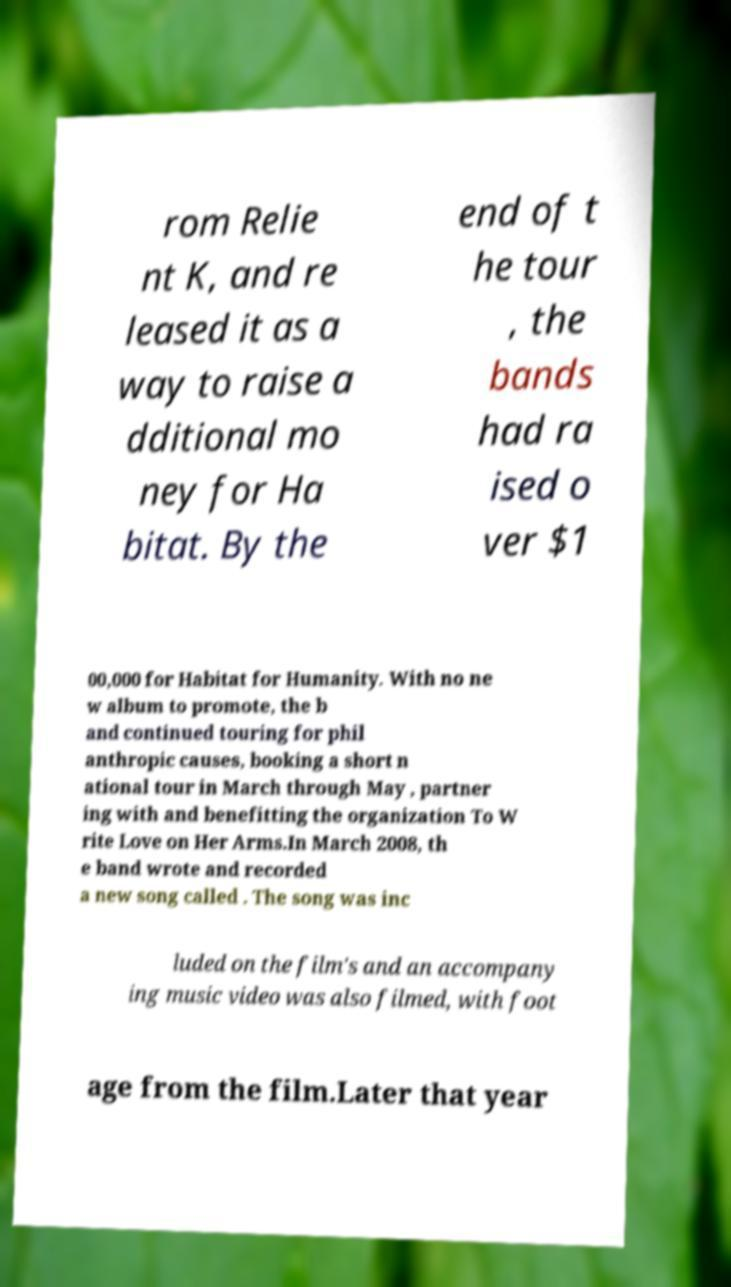Can you accurately transcribe the text from the provided image for me? rom Relie nt K, and re leased it as a way to raise a dditional mo ney for Ha bitat. By the end of t he tour , the bands had ra ised o ver $1 00,000 for Habitat for Humanity. With no ne w album to promote, the b and continued touring for phil anthropic causes, booking a short n ational tour in March through May , partner ing with and benefitting the organization To W rite Love on Her Arms.In March 2008, th e band wrote and recorded a new song called . The song was inc luded on the film's and an accompany ing music video was also filmed, with foot age from the film.Later that year 